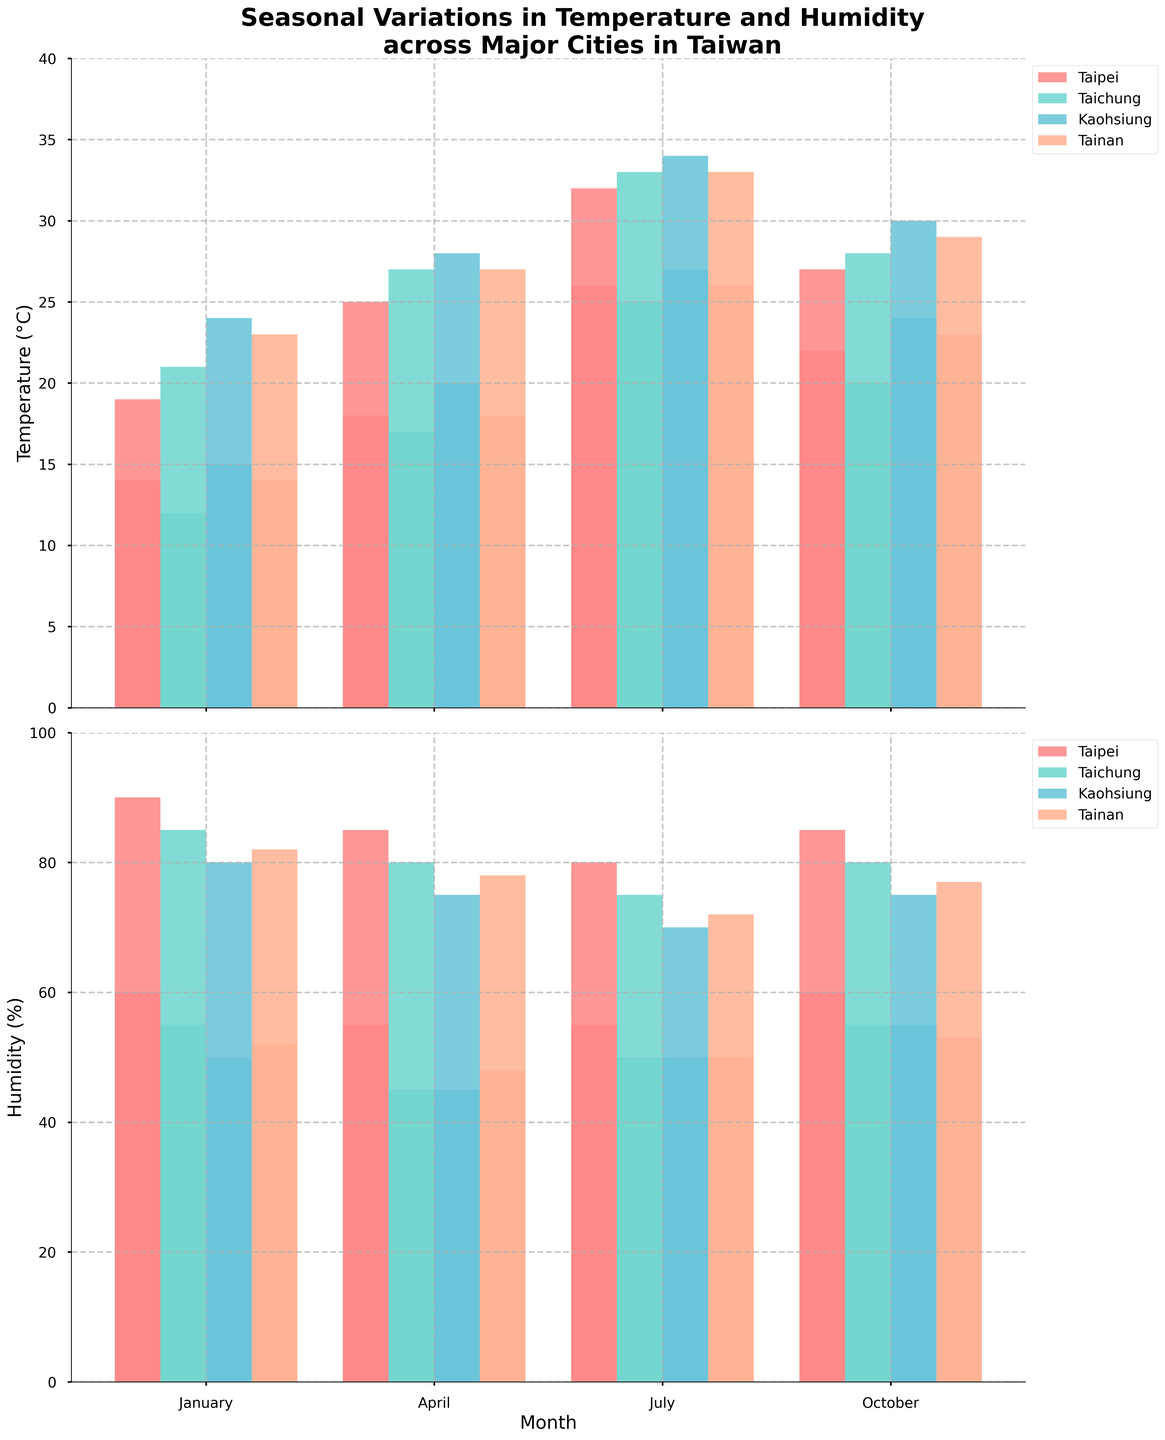What is the title of the figure? The title is positioned at the top of the figure. It reads "Seasonal Variations in Temperature and Humidity across Major Cities in Taiwan".
Answer: Seasonal Variations in Temperature and Humidity across Major Cities in Taiwan Which city has the highest temperature in July? By checking the highest bar for July in the "Temperature" section, we see that Kaohsiung's temperature reaches 34°C.
Answer: Kaohsiung Which city has the lowest humidity in January? In the "Humidity" section, the shortest bar in January represents Kaohsiung, with a low humidity of 50%.
Answer: Kaohsiung How does Taipei's average high temperature change from January to July? First, check Taipei's high temperatures in January (19°C) and July (32°C). The change is 32 - 19 = 13°C.
Answer: 13°C increase Which month shows the greatest range in temperatures for Tainan? Look at Tainan’s temperature bars for each month and calculate the ranges: January (23-14=9°C), April (27-18=9°C), July (33-26=7°C), October (29-23=6°C). January and April both have the greatest range of 9°C.
Answer: January and April Compare the high humidity levels between Taipei and Taichung in October. Which city has higher humidity, and by how much? In October, Taipei's high humidity is 85%, while Taichung's is 80%. The difference is 85 - 80 = 5%.
Answer: Taipei, 5% What is the average low temperature for all four cities in April? Add up the low temperatures for April: Taipei (18°C), Taichung (17°C), Kaohsiung (20°C), Tainan (18°C). The sum is 18 + 17 + 20 + 18 = 73°C. The average is 73 / 4 = 18.25°C.
Answer: 18.25°C Explain the seasonal variation pattern for temperature in Taichung. Check the high and low temperatures of Taichung in each season: January (21°C/12°C), April (27°C/17°C), July (33°C/25°C), October (28°C/20°C). The pattern shows that Taichung gets progressively warmer from January to July and then cools down slightly by October but remains warmer than in January and April.
Answer: Progressive increase till July, then slight decrease by October Identify the city with the smallest difference between high and low humidity throughout the year. Calculate each city's yearly average humidity difference: Taipei (90-55=35%; 85-55=30%; 80-55=25%; 85-60=25%, average = 28.75%), Taichung (85-55=30%; 80-45=35%; 75-50=25%; 80-55=25%, average = 28.75%), Kaohsiung (80-50=30%; 75-45=30%; 70-50=20%; 75-55=20%, average = 25%), Tainan (82-52=30%; 78-48=30%; 72-50=22%; 77-53=24%, average = 26.5%). Kaohsiung has the smallest difference with 25% average.
Answer: Kaohsiung, 25% average 